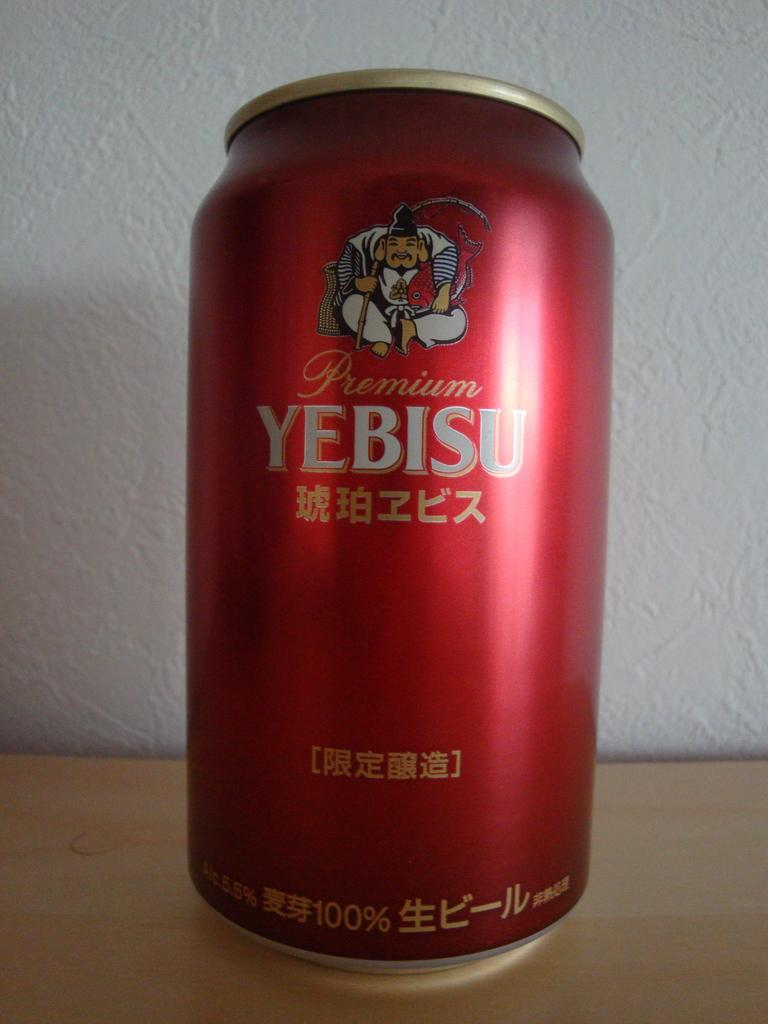Provide a one-sentence caption for the provided image. A red canned beveraged is labelled Premium Yebisu. 